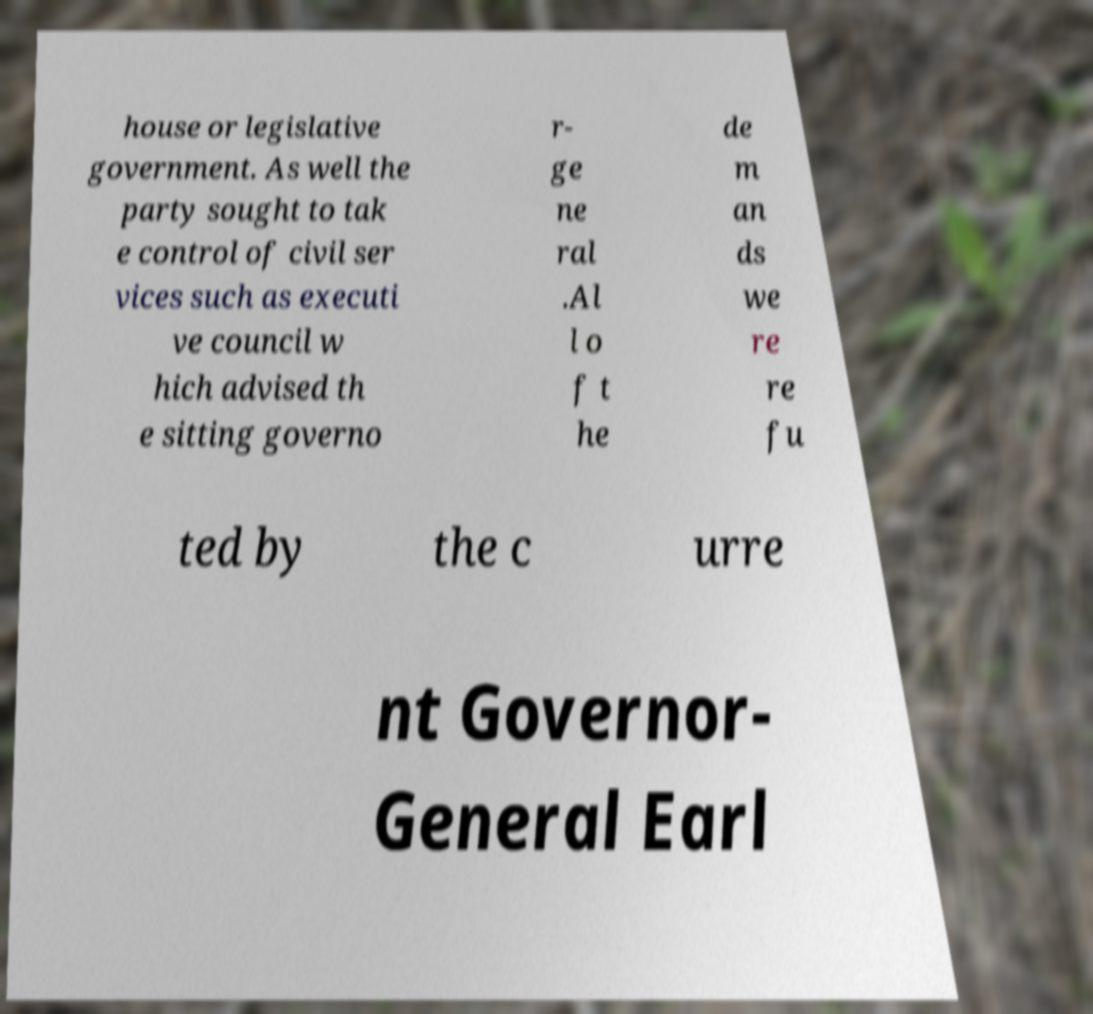There's text embedded in this image that I need extracted. Can you transcribe it verbatim? house or legislative government. As well the party sought to tak e control of civil ser vices such as executi ve council w hich advised th e sitting governo r- ge ne ral .Al l o f t he de m an ds we re re fu ted by the c urre nt Governor- General Earl 